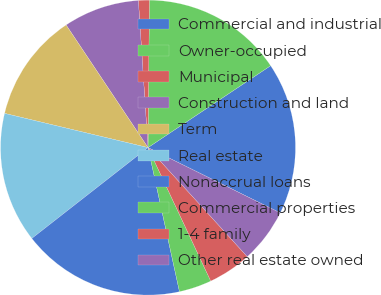Convert chart to OTSL. <chart><loc_0><loc_0><loc_500><loc_500><pie_chart><fcel>Commercial and industrial<fcel>Owner-occupied<fcel>Municipal<fcel>Construction and land<fcel>Term<fcel>Real estate<fcel>Nonaccrual loans<fcel>Commercial properties<fcel>1-4 family<fcel>Other real estate owned<nl><fcel>16.67%<fcel>15.48%<fcel>1.19%<fcel>8.33%<fcel>11.9%<fcel>14.29%<fcel>17.86%<fcel>3.57%<fcel>4.76%<fcel>5.95%<nl></chart> 